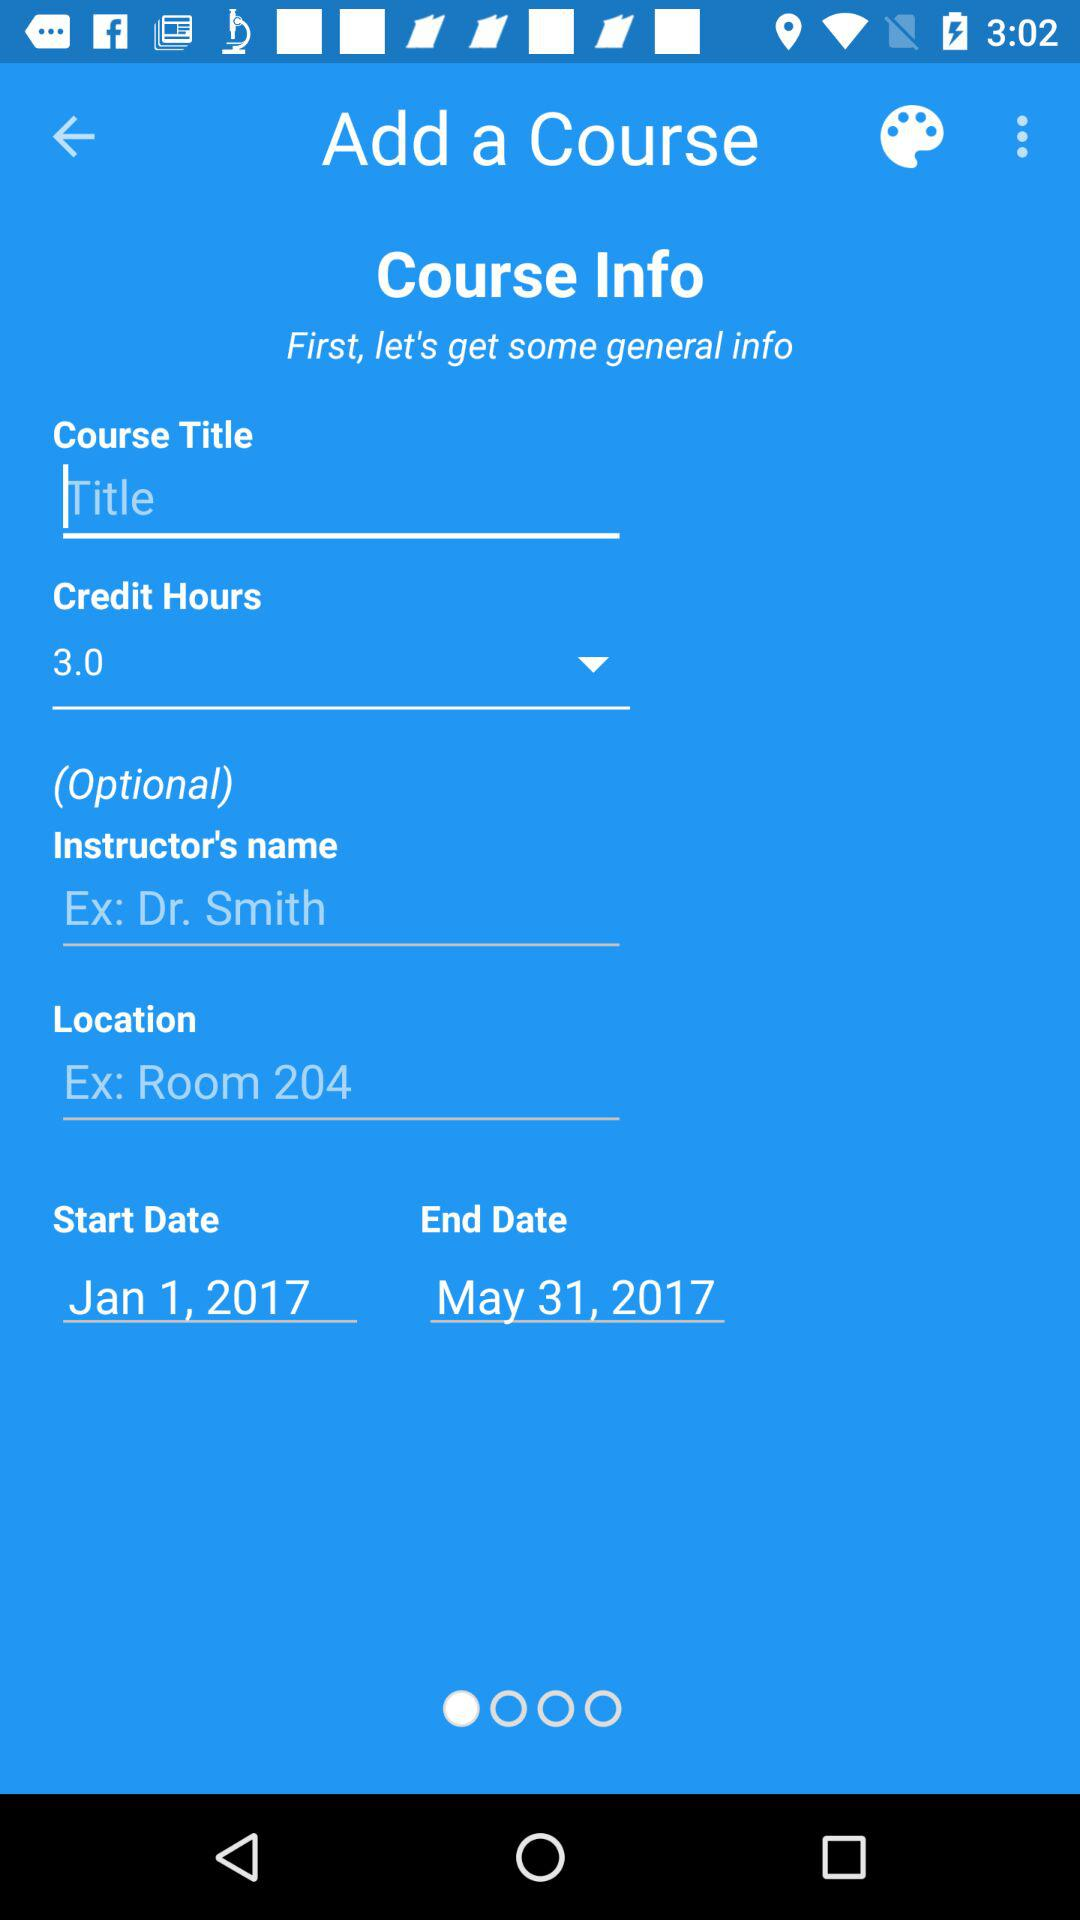What is the location?
When the provided information is insufficient, respond with <no answer>. <no answer> 